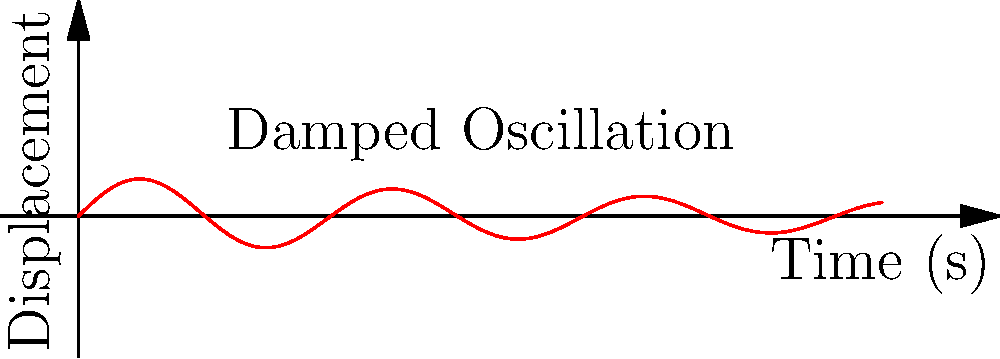In a content marketing campaign for a tech startup, you're creating an infographic about mechanical engineering concepts. You need to explain the natural frequency of a damped spring-mass system. Given a mass of 2 kg, spring constant of 200 N/m, and damping coefficient of 4 Ns/m, calculate the natural frequency of the system in Hz. To calculate the natural frequency of a damped spring-mass system, we'll follow these steps:

1. Recall the formula for natural frequency of a damped system:
   $$f_n = \frac{1}{2\pi} \sqrt{\frac{k}{m} - \left(\frac{c}{2m}\right)^2}$$
   Where:
   $f_n$ = natural frequency (Hz)
   $k$ = spring constant (N/m)
   $m$ = mass (kg)
   $c$ = damping coefficient (Ns/m)

2. Insert the given values:
   $k = 200$ N/m
   $m = 2$ kg
   $c = 4$ Ns/m

3. Calculate the term under the square root:
   $$\frac{k}{m} - \left(\frac{c}{2m}\right)^2 = \frac{200}{2} - \left(\frac{4}{2(2)}\right)^2 = 100 - 1 = 99$$

4. Take the square root:
   $$\sqrt{99} \approx 9.9499$$

5. Divide by $2\pi$:
   $$\frac{9.9499}{2\pi} \approx 1.5836$$

Therefore, the natural frequency of the damped system is approximately 1.58 Hz.
Answer: 1.58 Hz 